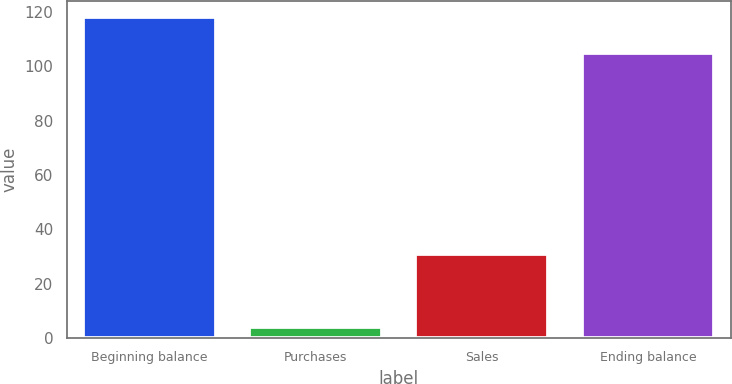Convert chart to OTSL. <chart><loc_0><loc_0><loc_500><loc_500><bar_chart><fcel>Beginning balance<fcel>Purchases<fcel>Sales<fcel>Ending balance<nl><fcel>118<fcel>4<fcel>31<fcel>105<nl></chart> 